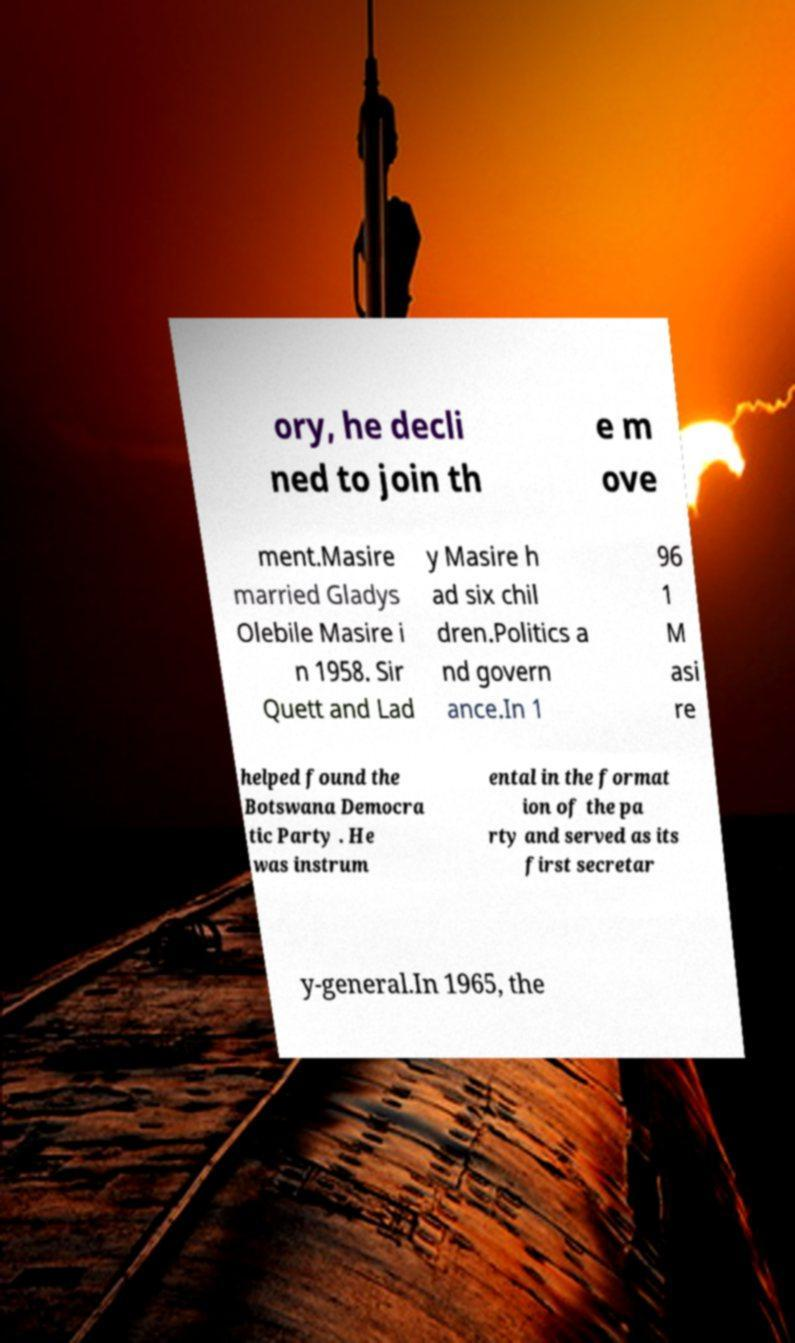Can you read and provide the text displayed in the image?This photo seems to have some interesting text. Can you extract and type it out for me? ory, he decli ned to join th e m ove ment.Masire married Gladys Olebile Masire i n 1958. Sir Quett and Lad y Masire h ad six chil dren.Politics a nd govern ance.In 1 96 1 M asi re helped found the Botswana Democra tic Party . He was instrum ental in the format ion of the pa rty and served as its first secretar y-general.In 1965, the 